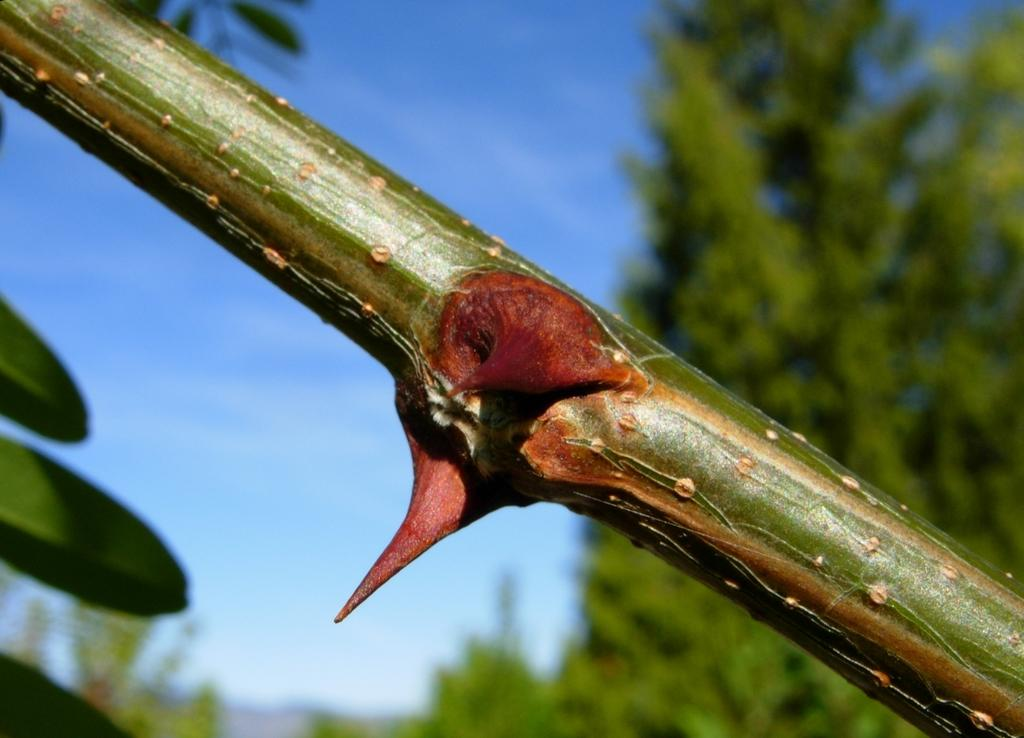What is the main subject in the middle of the image? There is a green color branch of a tree in the middle of the image. What can be seen in the background of the image? There are trees in the background of the image. What is visible in the sky in the image? There are clouds in the sky, and the sky is blue. What type of horn can be seen on the tree branch in the image? There is no horn present on the tree branch in the image. How many pies are visible on the tree branch in the image? There are no pies present on the tree branch in the image. 